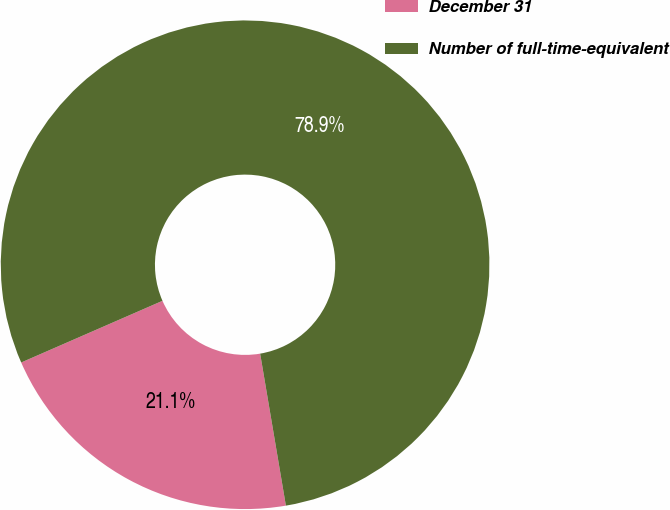Convert chart. <chart><loc_0><loc_0><loc_500><loc_500><pie_chart><fcel>December 31<fcel>Number of full-time-equivalent<nl><fcel>21.12%<fcel>78.88%<nl></chart> 